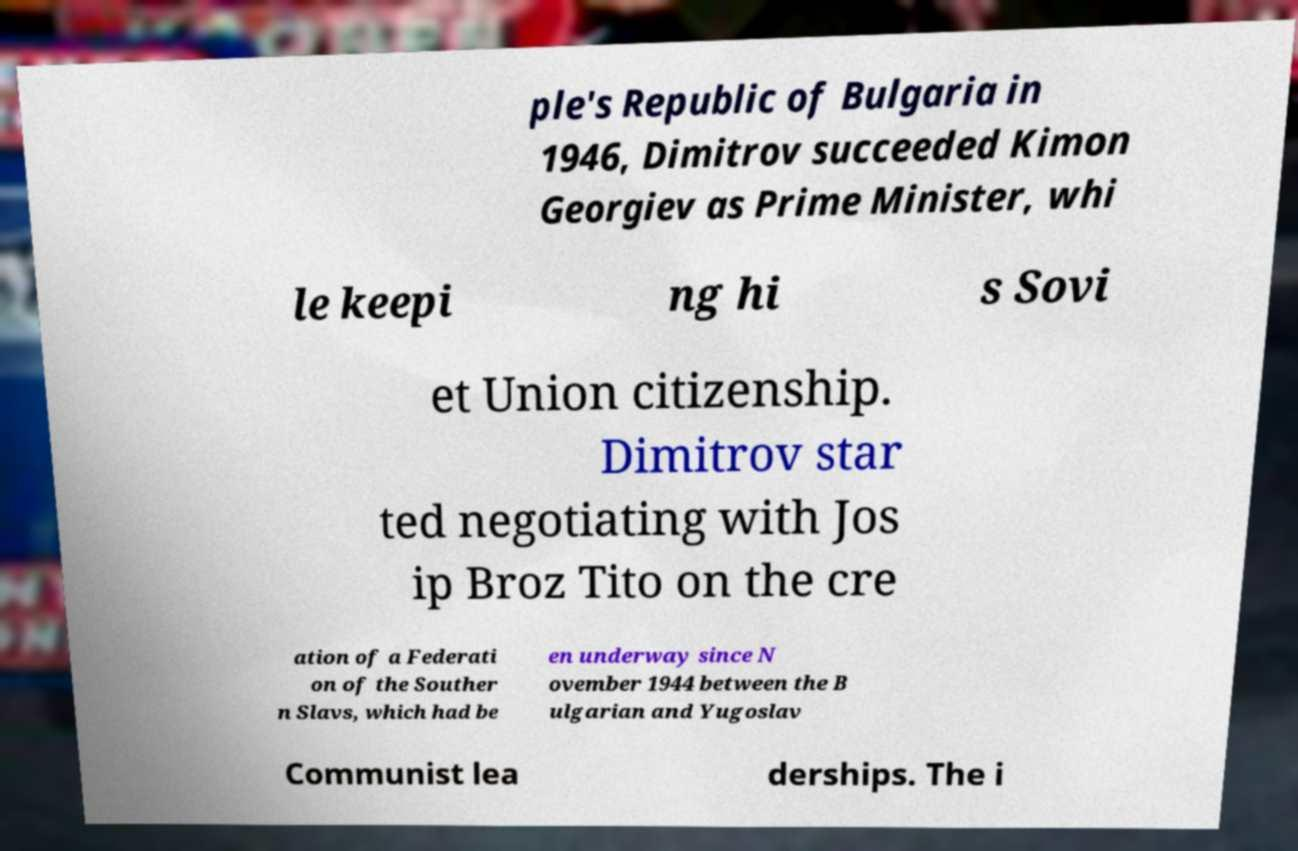Please read and relay the text visible in this image. What does it say? ple's Republic of Bulgaria in 1946, Dimitrov succeeded Kimon Georgiev as Prime Minister, whi le keepi ng hi s Sovi et Union citizenship. Dimitrov star ted negotiating with Jos ip Broz Tito on the cre ation of a Federati on of the Souther n Slavs, which had be en underway since N ovember 1944 between the B ulgarian and Yugoslav Communist lea derships. The i 